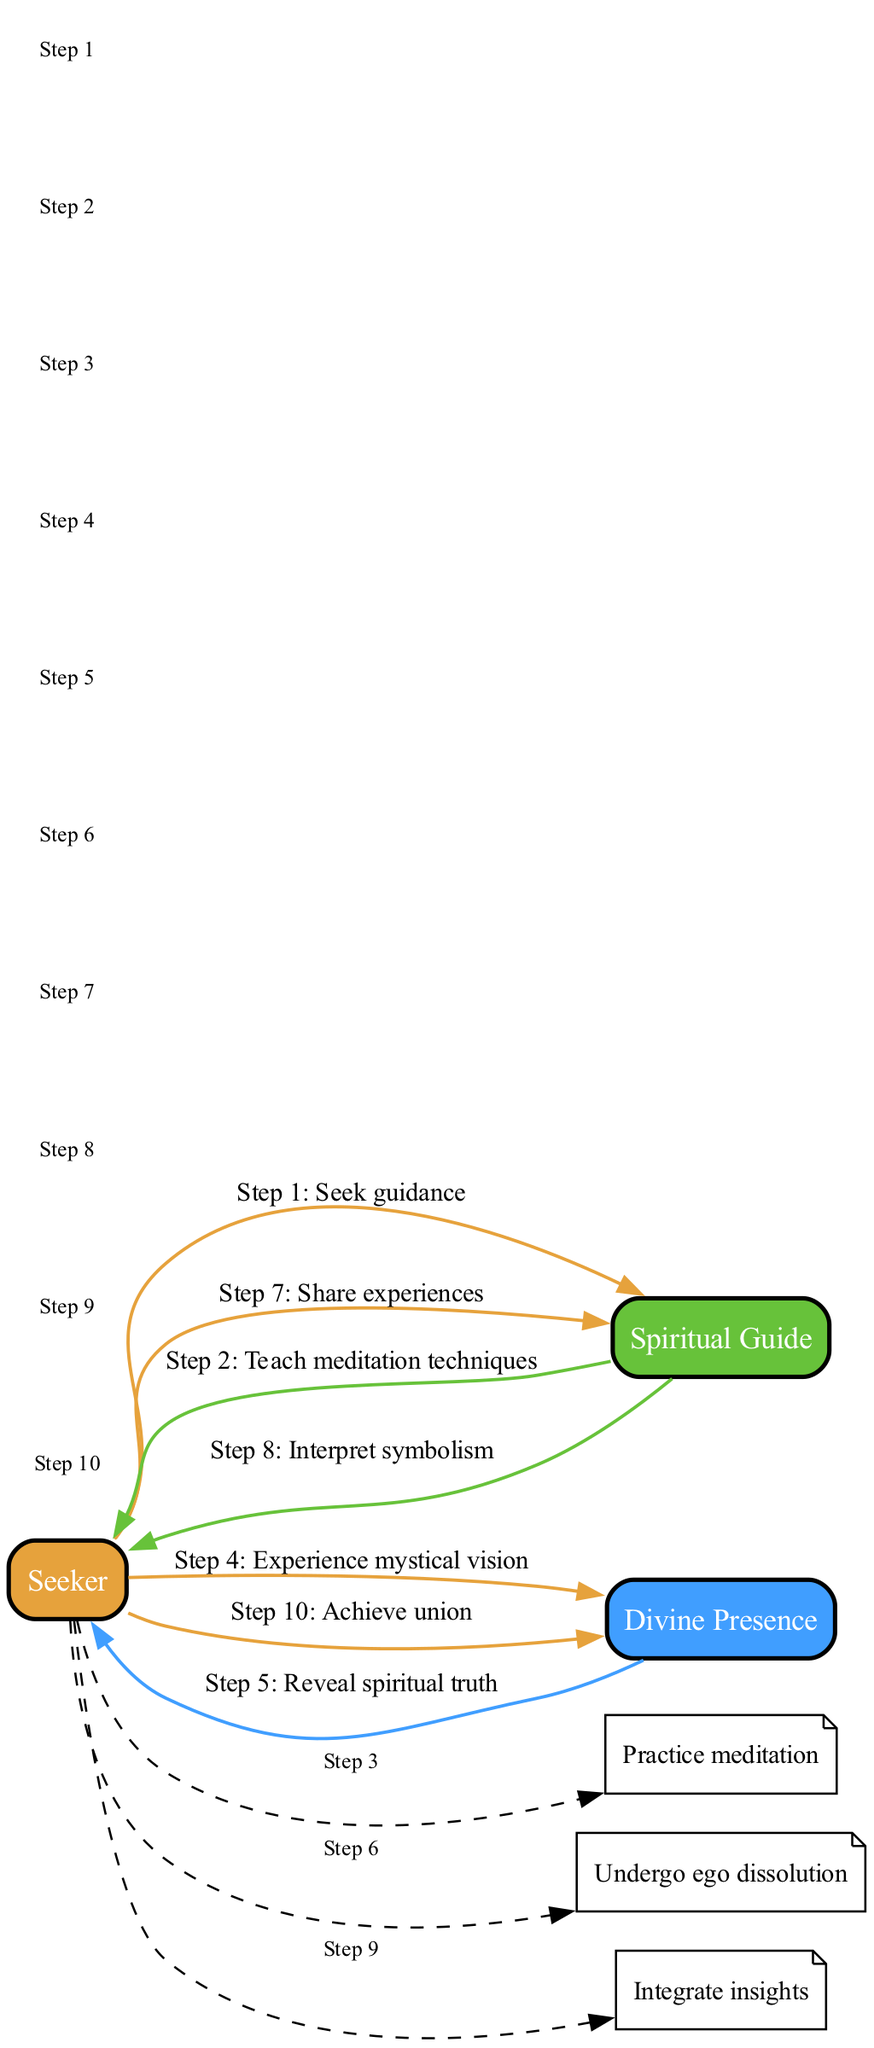What is the first action taken by the Seeker? The diagram shows that the Seeker initiates the process by seeking guidance from the Spiritual Guide.
Answer: Seek guidance How many interactions are represented in the diagram? There are a total of ten interactions represented in the sequence, as indicated by the number of steps connecting the participants.
Answer: 10 What message does the Divine Presence send to the Seeker? The diagram illustrates that the Divine Presence reveals spiritual truth to the Seeker after the mystical vision is experienced.
Answer: Reveal spiritual truth Which participant is involved in the action of sharing experiences? The diagram specifies that the Seeker is the participant who shares experiences with the Spiritual Guide after undergoing ego dissolution.
Answer: Seeker What step comes after practicing meditation? According to the flow in the diagram, the next action after the Seeker practices meditation is experiencing a mystical vision.
Answer: Experience mystical vision What relationship exists between the Seeker and the Spiritual Guide in the context of interpreting symbolism? The diagram indicates that the Spiritual Guide interprets the symbolism based on the experiences shared by the Seeker, showcasing a mentorship relationship.
Answer: Spiritual Guide How does the process of ego dissolution relate to integrating insights? The diagram shows that the Seeker undergoes ego dissolution followed by the integration of insights, suggesting that the former is a prerequisite for the latter.
Answer: Ego dissolution What is the last step in the spiritual awakening process? The final step in the sequence indicates that the Seeker achieves union with the Divine Presence, culminating the spiritual awakening process.
Answer: Achieve union 